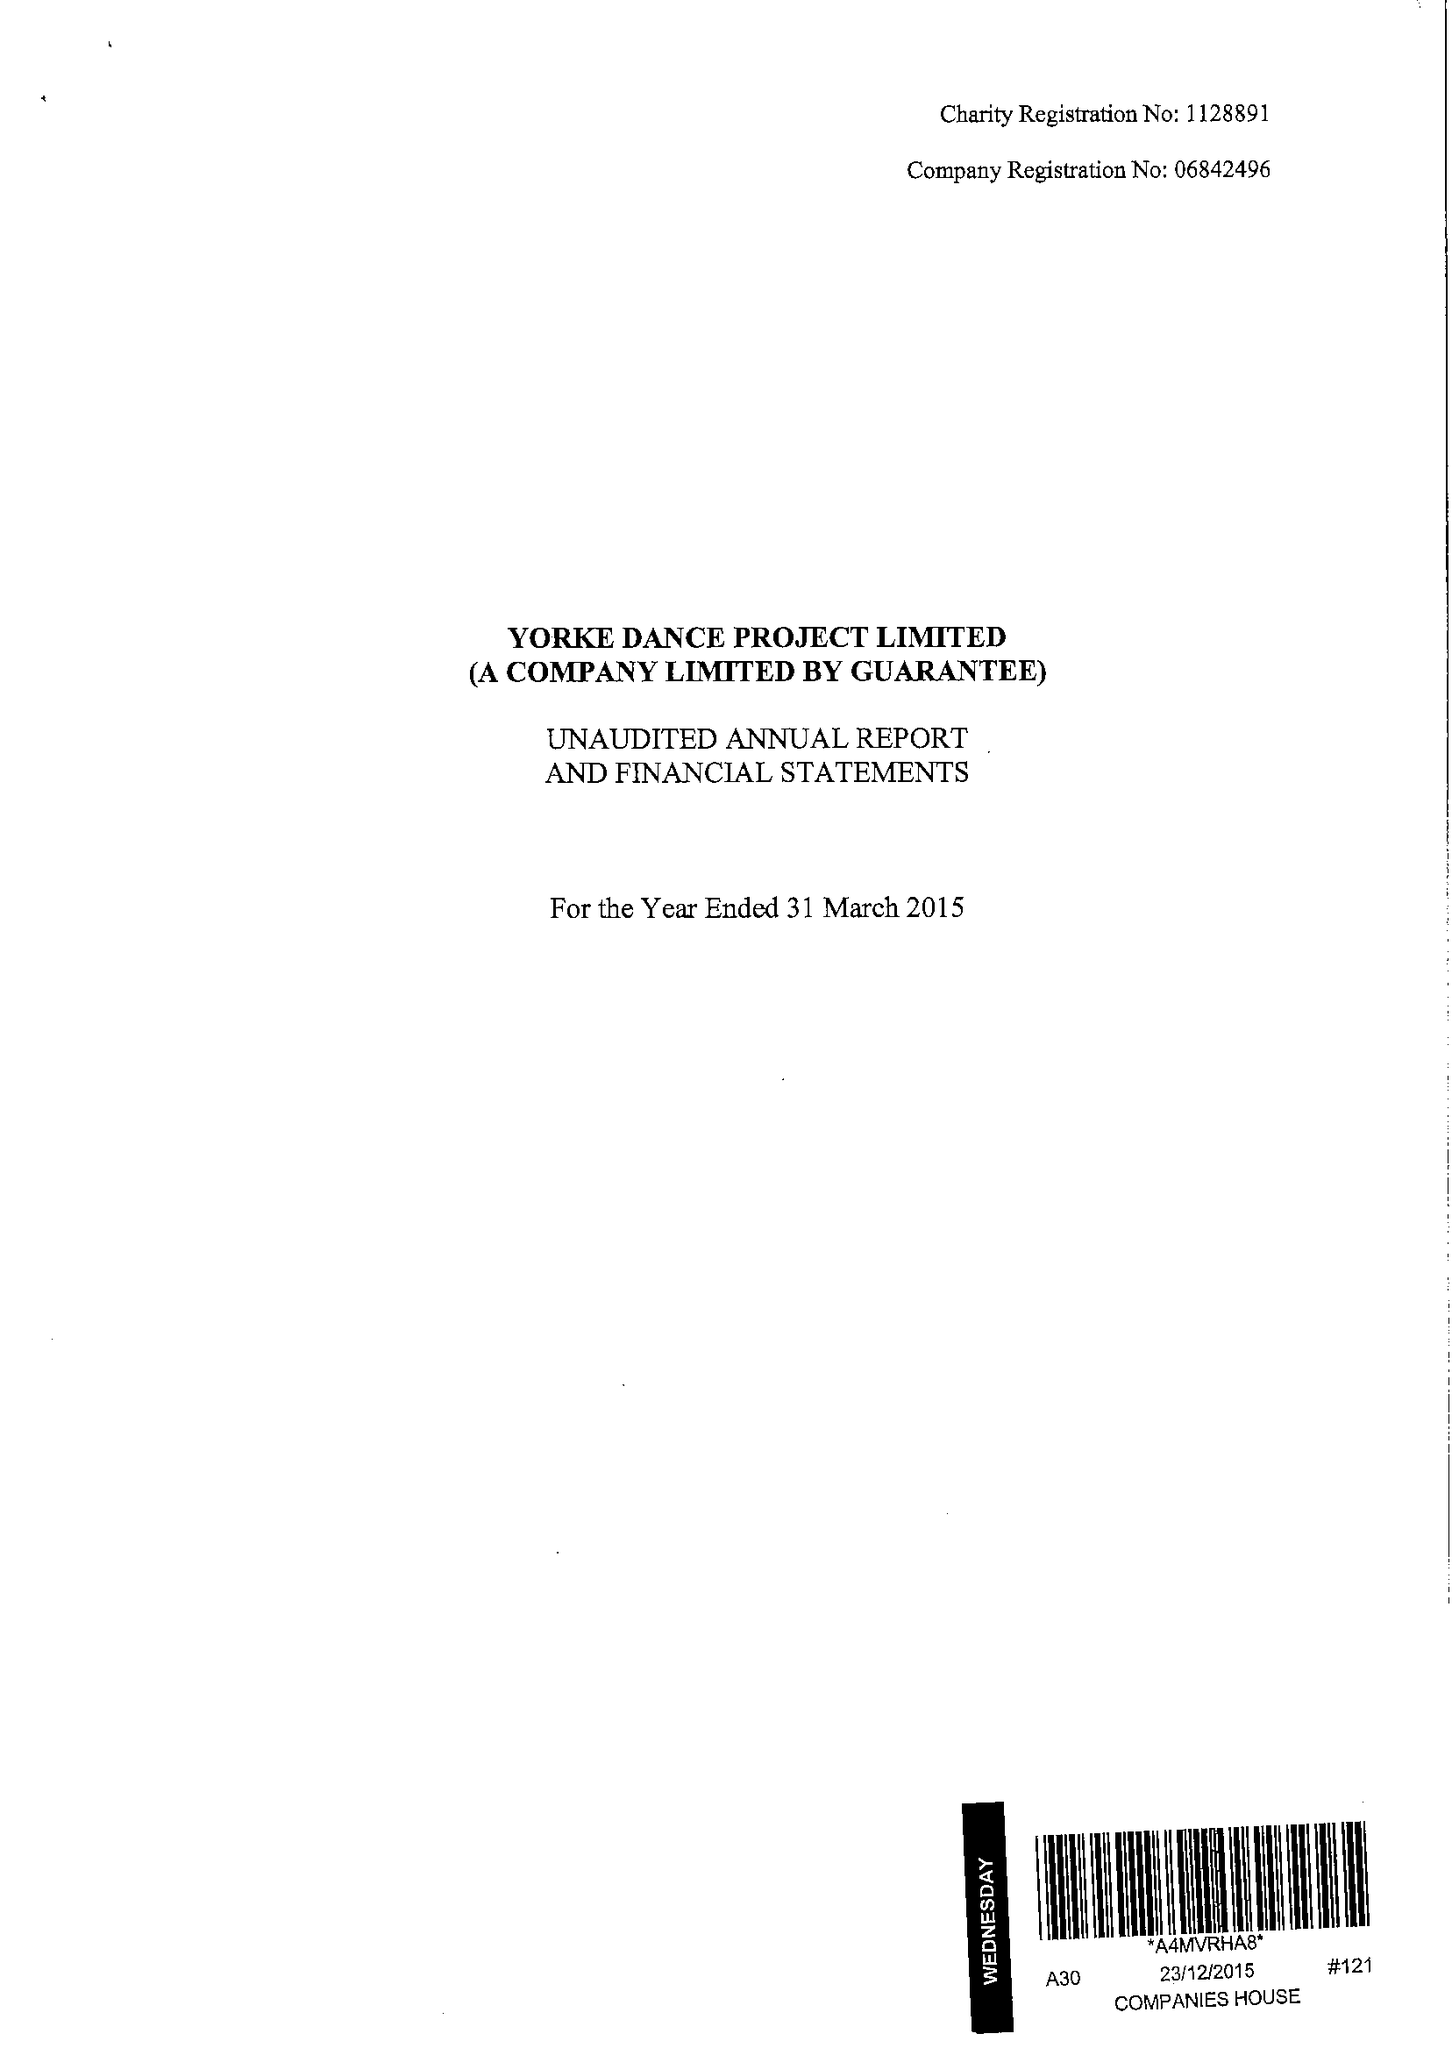What is the value for the charity_number?
Answer the question using a single word or phrase. 1128891 